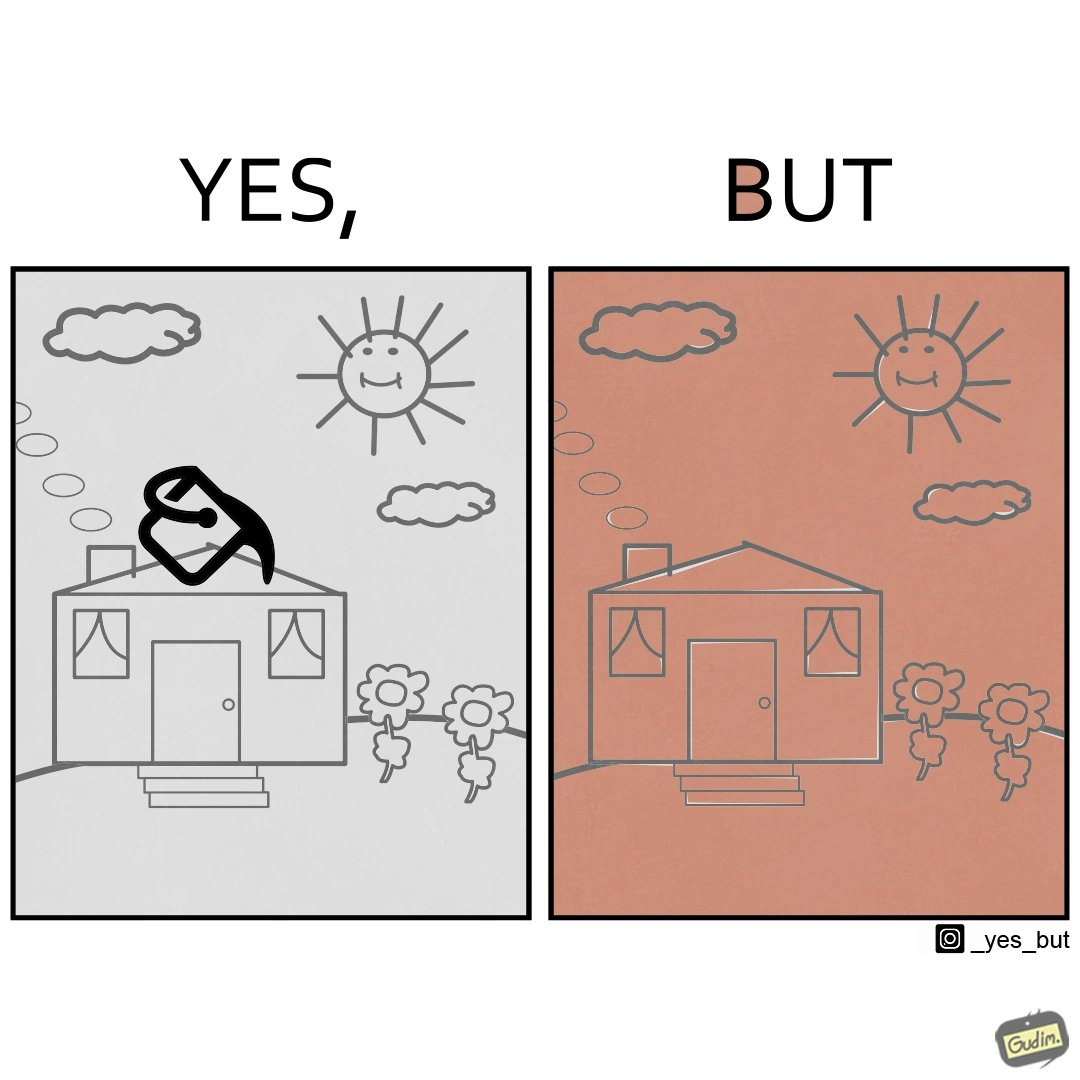Would you classify this image as satirical? Yes, this image is satirical. 